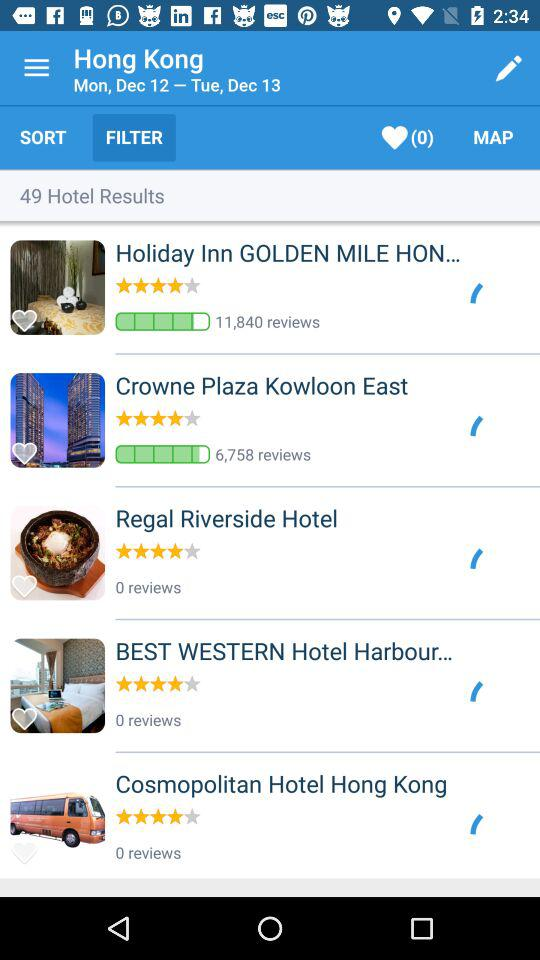How many hotels have 0 reviews?
Answer the question using a single word or phrase. 3 